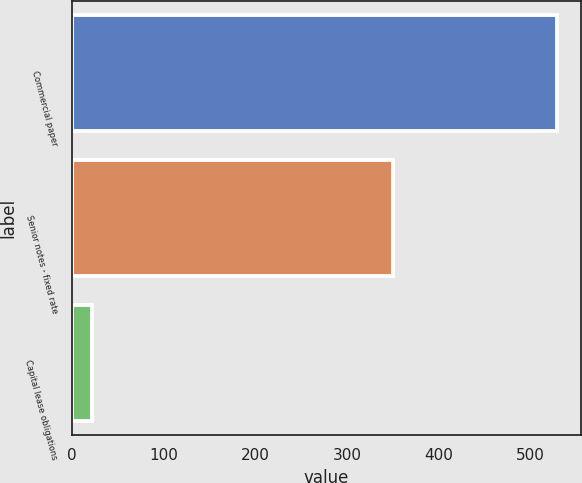<chart> <loc_0><loc_0><loc_500><loc_500><bar_chart><fcel>Commercial paper<fcel>Senior notes - fixed rate<fcel>Capital lease obligations<nl><fcel>528.9<fcel>350<fcel>21.5<nl></chart> 